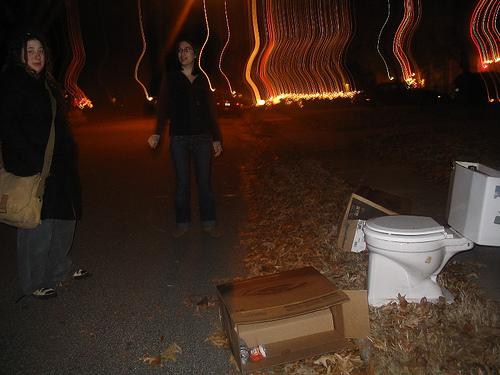How many objects are in the box?
Concise answer only. 2. Is it lightening outside?
Keep it brief. No. What is sitting outside in the grass?
Be succinct. Toilet. 